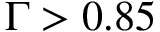<formula> <loc_0><loc_0><loc_500><loc_500>\Gamma > 0 . 8 5</formula> 